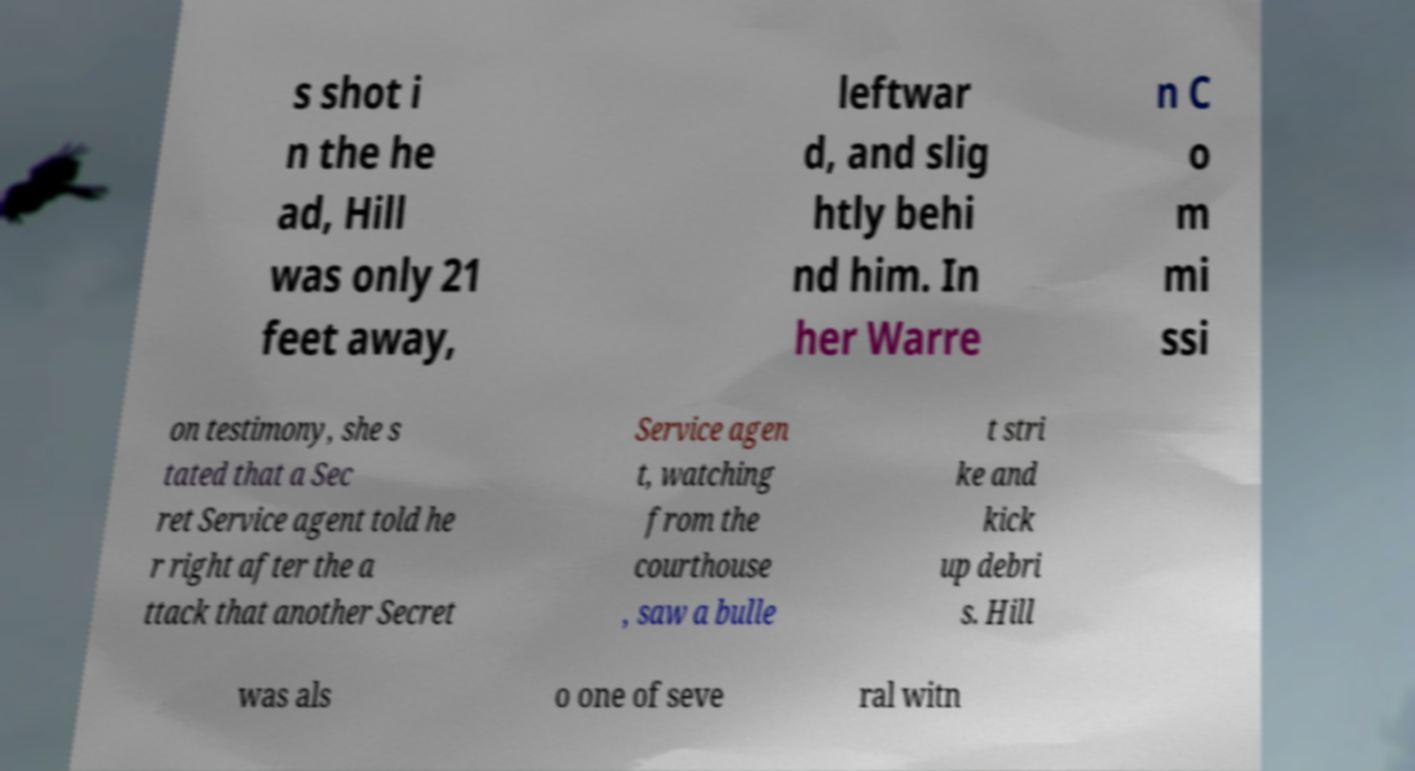Can you accurately transcribe the text from the provided image for me? s shot i n the he ad, Hill was only 21 feet away, leftwar d, and slig htly behi nd him. In her Warre n C o m mi ssi on testimony, she s tated that a Sec ret Service agent told he r right after the a ttack that another Secret Service agen t, watching from the courthouse , saw a bulle t stri ke and kick up debri s. Hill was als o one of seve ral witn 